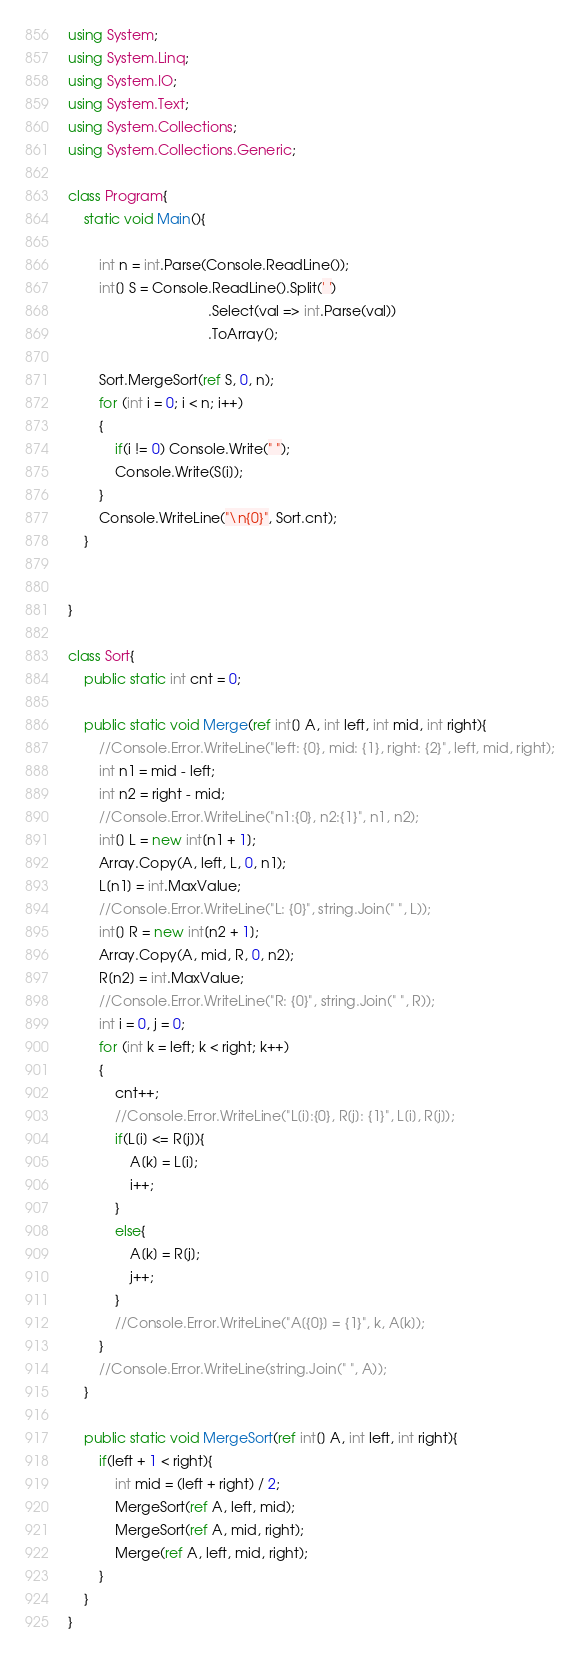<code> <loc_0><loc_0><loc_500><loc_500><_C#_>using System;
using System.Linq;
using System.IO;
using System.Text;
using System.Collections;
using System.Collections.Generic;
 
class Program{
    static void Main(){

        int n = int.Parse(Console.ReadLine());
        int[] S = Console.ReadLine().Split(' ')
                                    .Select(val => int.Parse(val))
                                    .ToArray();
        
        Sort.MergeSort(ref S, 0, n);
        for (int i = 0; i < n; i++)
        {
            if(i != 0) Console.Write(" ");
            Console.Write(S[i]);
        }
        Console.WriteLine("\n{0}", Sort.cnt);
    }

    
}

class Sort{
    public static int cnt = 0;

    public static void Merge(ref int[] A, int left, int mid, int right){
        //Console.Error.WriteLine("left: {0}, mid: {1}, right: {2}", left, mid, right);
        int n1 = mid - left;
        int n2 = right - mid;
        //Console.Error.WriteLine("n1:{0}, n2:{1}", n1, n2);
        int[] L = new int[n1 + 1];
        Array.Copy(A, left, L, 0, n1);
        L[n1] = int.MaxValue;
        //Console.Error.WriteLine("L: {0}", string.Join(" ", L));
        int[] R = new int[n2 + 1];
        Array.Copy(A, mid, R, 0, n2);
        R[n2] = int.MaxValue;
        //Console.Error.WriteLine("R: {0}", string.Join(" ", R));
        int i = 0, j = 0;
        for (int k = left; k < right; k++)
        {
            cnt++;
            //Console.Error.WriteLine("L[i]:{0}, R[j]: {1}", L[i], R[j]);
            if(L[i] <= R[j]){
                A[k] = L[i];
                i++;
            }
            else{
                A[k] = R[j];
                j++;
            }
            //Console.Error.WriteLine("A[{0}] = {1}", k, A[k]);
        }
        //Console.Error.WriteLine(string.Join(" ", A));
    }

    public static void MergeSort(ref int[] A, int left, int right){
        if(left + 1 < right){
            int mid = (left + right) / 2;
            MergeSort(ref A, left, mid);
            MergeSort(ref A, mid, right);
            Merge(ref A, left, mid, right);
        }
    }
}</code> 